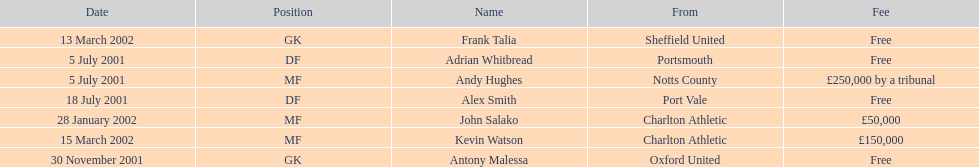What is the total number of free fees? 4. 